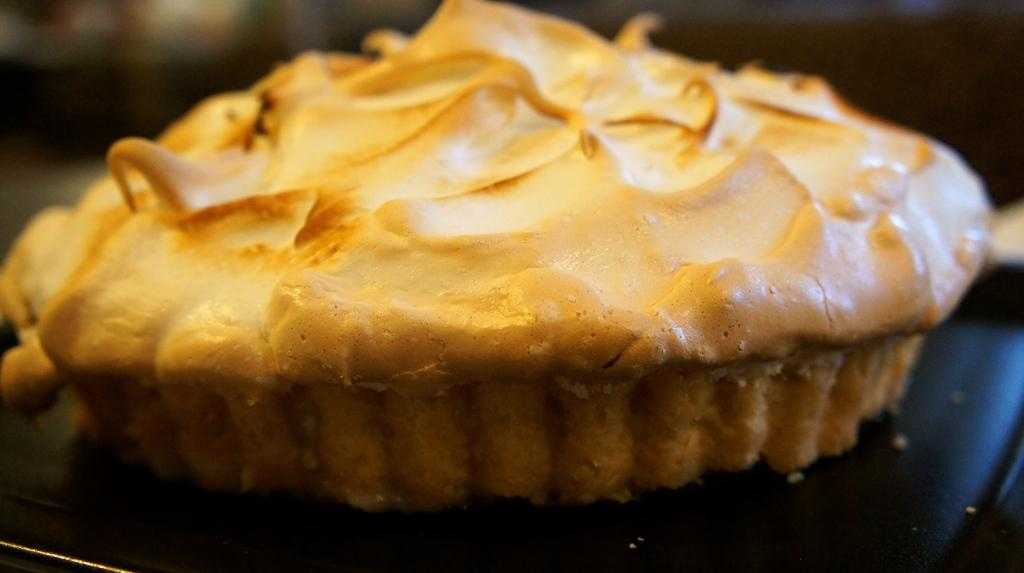What is the main subject of the image? There is a cake in the image. What is the cake placed on? The cake is on a black plate. Can you describe the background of the image? The background of the image is blurred. What type of farm animals can be seen in the image? There are no farm animals present in the image; it features a cake on a black plate with a blurred background. What kind of cave is visible in the image? There is no cave present in the image; it features a cake on a black plate with a blurred background. 